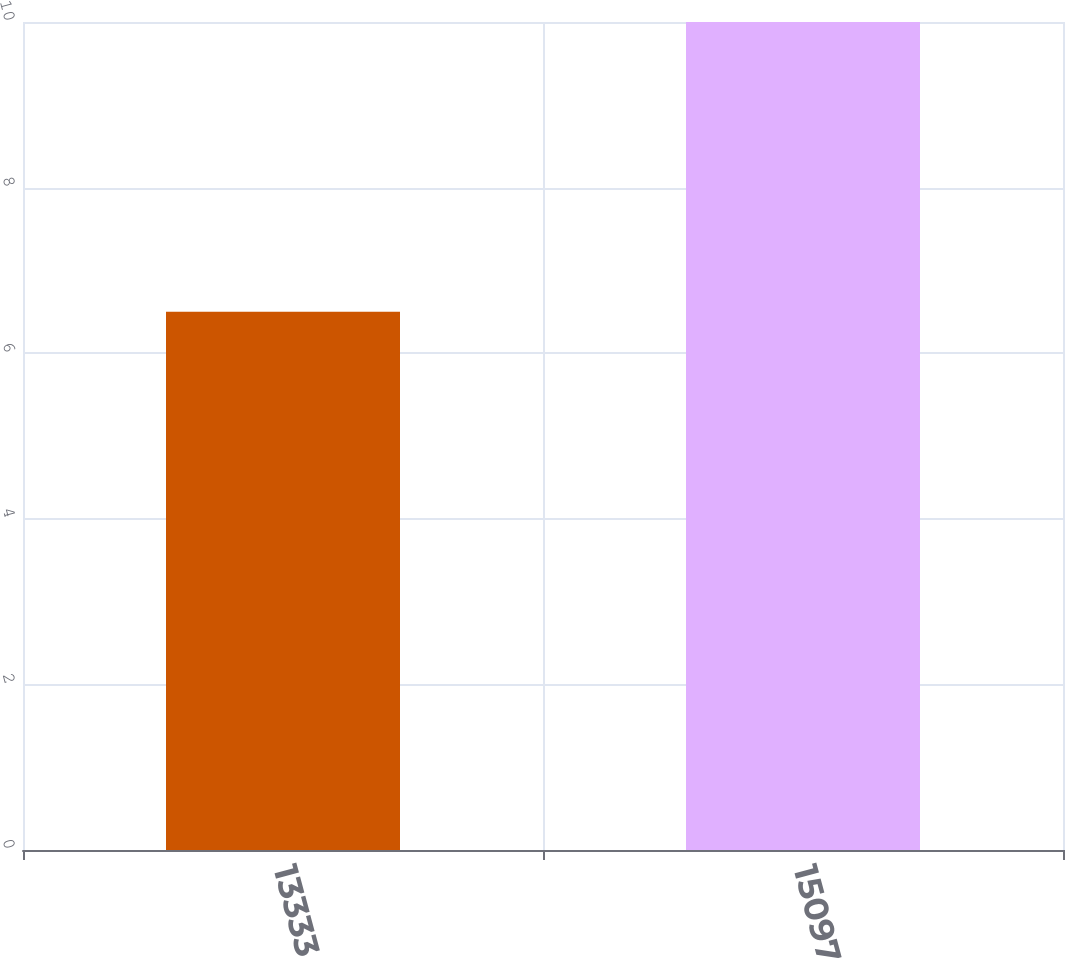Convert chart to OTSL. <chart><loc_0><loc_0><loc_500><loc_500><bar_chart><fcel>13333<fcel>15097<nl><fcel>6.5<fcel>10<nl></chart> 